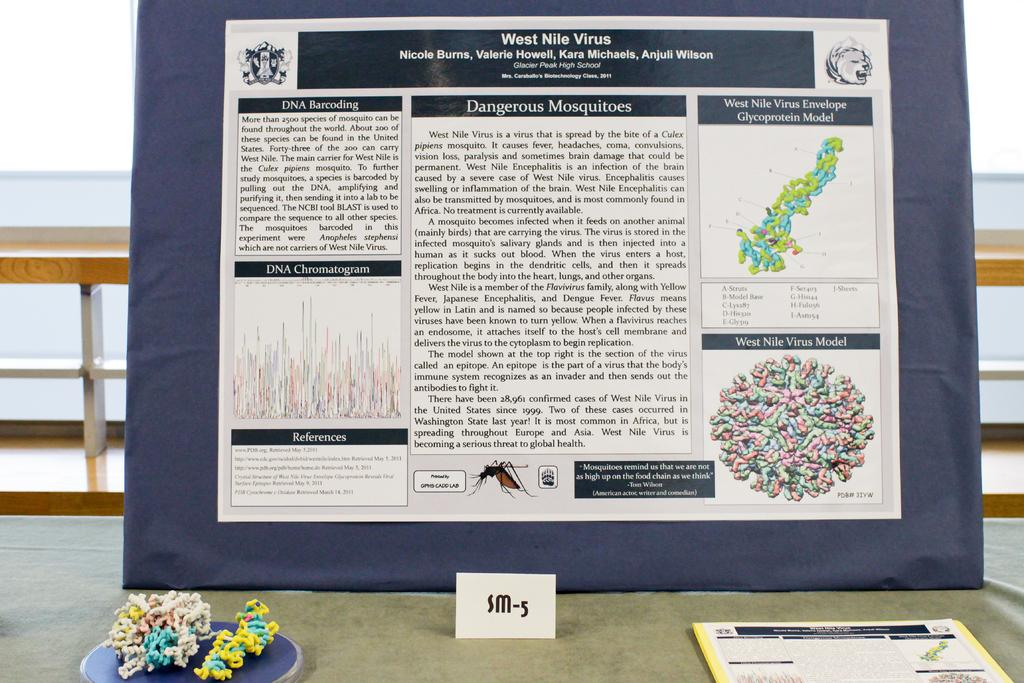What is on the board in the image? There is a printed paper on the board in the image. What is placed on the cloth in the image? There is a book on the cloth in the image. What type of structure can be seen in the image? There is a wooden fence in the image. What type of cover is protecting the book from the ice in the image? There is no ice or cover present in the image. Is there a tent visible in the image? No, there is no tent present in the image. 